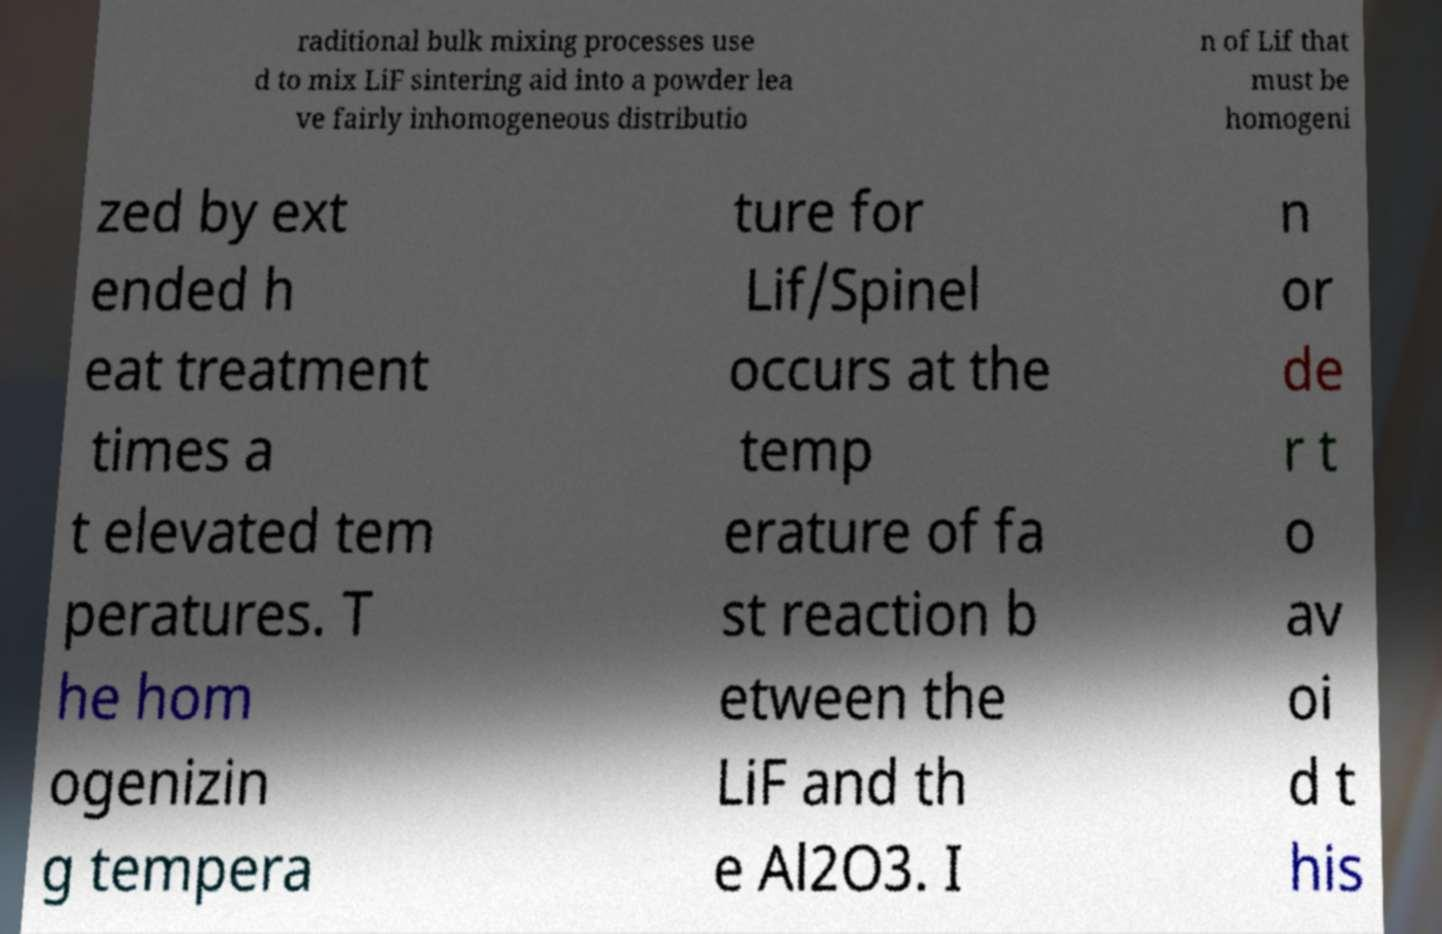What messages or text are displayed in this image? I need them in a readable, typed format. raditional bulk mixing processes use d to mix LiF sintering aid into a powder lea ve fairly inhomogeneous distributio n of Lif that must be homogeni zed by ext ended h eat treatment times a t elevated tem peratures. T he hom ogenizin g tempera ture for Lif/Spinel occurs at the temp erature of fa st reaction b etween the LiF and th e Al2O3. I n or de r t o av oi d t his 